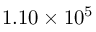Convert formula to latex. <formula><loc_0><loc_0><loc_500><loc_500>1 . 1 0 \times 1 0 ^ { 5 }</formula> 